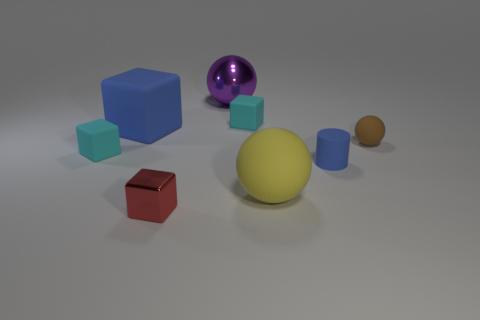Do the blue rubber cylinder and the brown rubber object have the same size?
Keep it short and to the point. Yes. Is the size of the metal ball the same as the cyan rubber object in front of the brown rubber object?
Offer a very short reply. No. What color is the big sphere behind the cyan matte block that is to the left of the large matte object that is on the left side of the large yellow matte ball?
Your answer should be very brief. Purple. Does the tiny cyan object to the left of the large blue rubber cube have the same material as the tiny brown object?
Your answer should be compact. Yes. How many other objects are the same material as the large purple thing?
Offer a very short reply. 1. There is a blue object that is the same size as the purple thing; what is it made of?
Ensure brevity in your answer.  Rubber. There is a small object in front of the yellow matte thing; is its shape the same as the big blue matte thing behind the blue rubber cylinder?
Provide a succinct answer. Yes. There is a blue thing that is the same size as the purple object; what is its shape?
Keep it short and to the point. Cube. Is the material of the tiny cyan cube on the right side of the red metal object the same as the big ball behind the big blue object?
Ensure brevity in your answer.  No. Is there a matte cube to the left of the big blue rubber object left of the purple thing?
Provide a succinct answer. Yes. 